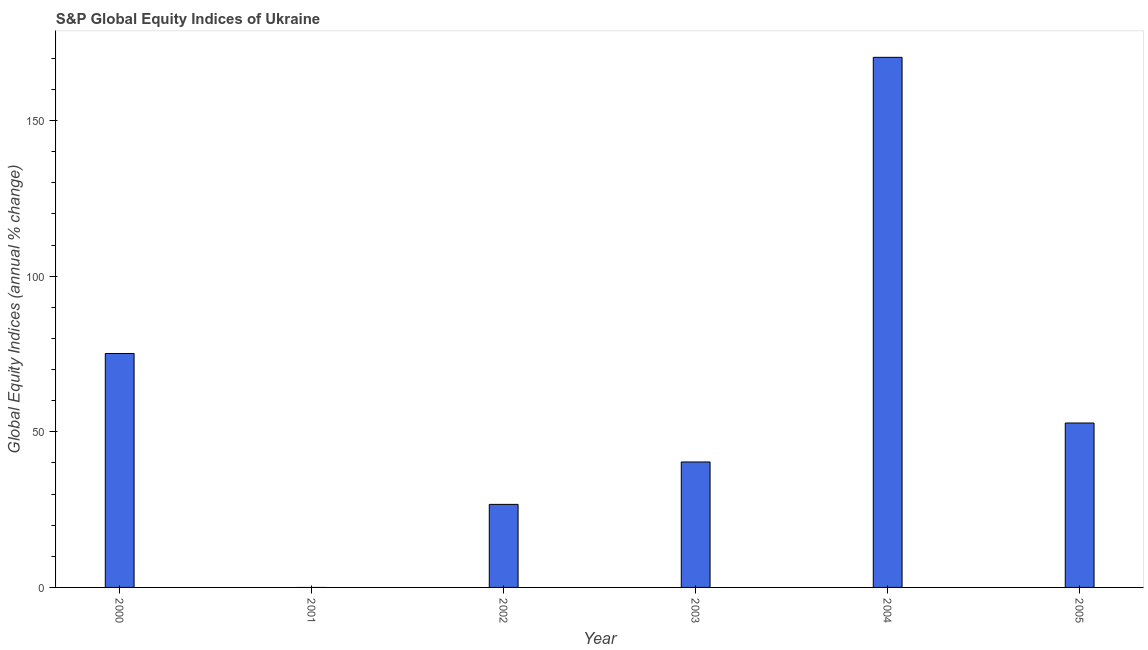Does the graph contain any zero values?
Your response must be concise. Yes. What is the title of the graph?
Provide a succinct answer. S&P Global Equity Indices of Ukraine. What is the label or title of the X-axis?
Keep it short and to the point. Year. What is the label or title of the Y-axis?
Your answer should be compact. Global Equity Indices (annual % change). What is the s&p global equity indices in 2001?
Offer a terse response. 0. Across all years, what is the maximum s&p global equity indices?
Offer a very short reply. 170.3. What is the sum of the s&p global equity indices?
Your answer should be very brief. 365.25. What is the difference between the s&p global equity indices in 2004 and 2005?
Offer a terse response. 117.48. What is the average s&p global equity indices per year?
Provide a succinct answer. 60.88. What is the median s&p global equity indices?
Your answer should be very brief. 46.56. What is the ratio of the s&p global equity indices in 2003 to that in 2005?
Provide a short and direct response. 0.76. Is the s&p global equity indices in 2003 less than that in 2004?
Provide a short and direct response. Yes. What is the difference between the highest and the second highest s&p global equity indices?
Offer a very short reply. 95.15. Is the sum of the s&p global equity indices in 2003 and 2004 greater than the maximum s&p global equity indices across all years?
Your response must be concise. Yes. What is the difference between the highest and the lowest s&p global equity indices?
Ensure brevity in your answer.  170.3. In how many years, is the s&p global equity indices greater than the average s&p global equity indices taken over all years?
Offer a terse response. 2. How many years are there in the graph?
Make the answer very short. 6. What is the difference between two consecutive major ticks on the Y-axis?
Make the answer very short. 50. Are the values on the major ticks of Y-axis written in scientific E-notation?
Offer a terse response. No. What is the Global Equity Indices (annual % change) in 2000?
Keep it short and to the point. 75.15. What is the Global Equity Indices (annual % change) in 2002?
Your response must be concise. 26.68. What is the Global Equity Indices (annual % change) of 2003?
Provide a short and direct response. 40.3. What is the Global Equity Indices (annual % change) of 2004?
Your answer should be compact. 170.3. What is the Global Equity Indices (annual % change) in 2005?
Ensure brevity in your answer.  52.82. What is the difference between the Global Equity Indices (annual % change) in 2000 and 2002?
Provide a short and direct response. 48.47. What is the difference between the Global Equity Indices (annual % change) in 2000 and 2003?
Make the answer very short. 34.85. What is the difference between the Global Equity Indices (annual % change) in 2000 and 2004?
Provide a succinct answer. -95.15. What is the difference between the Global Equity Indices (annual % change) in 2000 and 2005?
Provide a short and direct response. 22.33. What is the difference between the Global Equity Indices (annual % change) in 2002 and 2003?
Keep it short and to the point. -13.62. What is the difference between the Global Equity Indices (annual % change) in 2002 and 2004?
Give a very brief answer. -143.62. What is the difference between the Global Equity Indices (annual % change) in 2002 and 2005?
Offer a very short reply. -26.14. What is the difference between the Global Equity Indices (annual % change) in 2003 and 2004?
Keep it short and to the point. -130. What is the difference between the Global Equity Indices (annual % change) in 2003 and 2005?
Offer a very short reply. -12.52. What is the difference between the Global Equity Indices (annual % change) in 2004 and 2005?
Offer a terse response. 117.48. What is the ratio of the Global Equity Indices (annual % change) in 2000 to that in 2002?
Your response must be concise. 2.82. What is the ratio of the Global Equity Indices (annual % change) in 2000 to that in 2003?
Give a very brief answer. 1.86. What is the ratio of the Global Equity Indices (annual % change) in 2000 to that in 2004?
Provide a short and direct response. 0.44. What is the ratio of the Global Equity Indices (annual % change) in 2000 to that in 2005?
Make the answer very short. 1.42. What is the ratio of the Global Equity Indices (annual % change) in 2002 to that in 2003?
Offer a terse response. 0.66. What is the ratio of the Global Equity Indices (annual % change) in 2002 to that in 2004?
Keep it short and to the point. 0.16. What is the ratio of the Global Equity Indices (annual % change) in 2002 to that in 2005?
Your answer should be very brief. 0.51. What is the ratio of the Global Equity Indices (annual % change) in 2003 to that in 2004?
Your answer should be very brief. 0.24. What is the ratio of the Global Equity Indices (annual % change) in 2003 to that in 2005?
Offer a terse response. 0.76. What is the ratio of the Global Equity Indices (annual % change) in 2004 to that in 2005?
Make the answer very short. 3.22. 